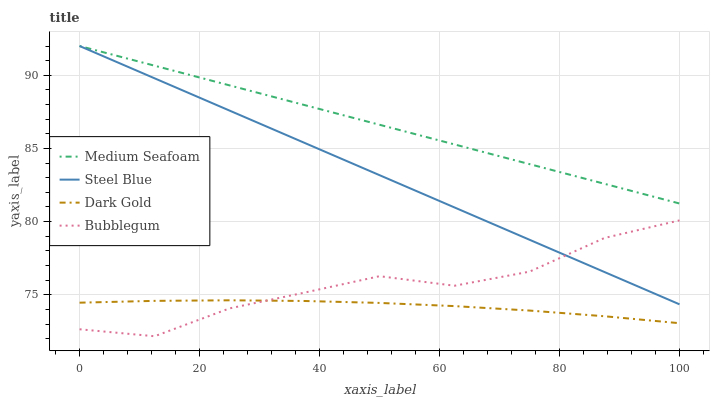Does Dark Gold have the minimum area under the curve?
Answer yes or no. Yes. Does Medium Seafoam have the maximum area under the curve?
Answer yes or no. Yes. Does Bubblegum have the minimum area under the curve?
Answer yes or no. No. Does Bubblegum have the maximum area under the curve?
Answer yes or no. No. Is Medium Seafoam the smoothest?
Answer yes or no. Yes. Is Bubblegum the roughest?
Answer yes or no. Yes. Is Bubblegum the smoothest?
Answer yes or no. No. Is Medium Seafoam the roughest?
Answer yes or no. No. Does Bubblegum have the lowest value?
Answer yes or no. Yes. Does Medium Seafoam have the lowest value?
Answer yes or no. No. Does Steel Blue have the highest value?
Answer yes or no. Yes. Does Bubblegum have the highest value?
Answer yes or no. No. Is Dark Gold less than Steel Blue?
Answer yes or no. Yes. Is Medium Seafoam greater than Dark Gold?
Answer yes or no. Yes. Does Steel Blue intersect Medium Seafoam?
Answer yes or no. Yes. Is Steel Blue less than Medium Seafoam?
Answer yes or no. No. Is Steel Blue greater than Medium Seafoam?
Answer yes or no. No. Does Dark Gold intersect Steel Blue?
Answer yes or no. No. 